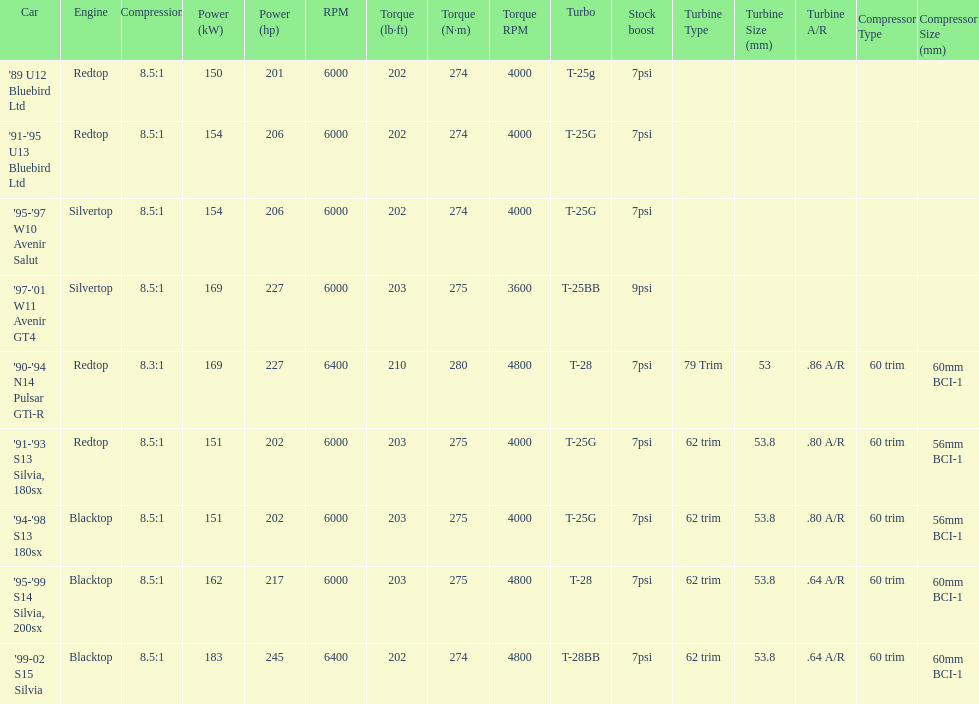Would you be able to parse every entry in this table? {'header': ['Car', 'Engine', 'Compression', 'Power (kW)', 'Power (hp)', 'RPM', 'Torque (lb·ft)', 'Torque (N·m)', 'Torque RPM', 'Turbo', 'Stock boost', 'Turbine Type', 'Turbine Size (mm)', 'Turbine A/R', 'Compressor Type', 'Compressor Size (mm)'], 'rows': [["'89 U12 Bluebird Ltd", 'Redtop', '8.5:1', '150', '201', '6000', '202', '274', '4000', 'T-25g', '7psi', '', '', '', '', ''], ["'91-'95 U13 Bluebird Ltd", 'Redtop', '8.5:1', '154', '206', '6000', '202', '274', '4000', 'T-25G', '7psi', '', '', '', '', ''], ["'95-'97 W10 Avenir Salut", 'Silvertop', '8.5:1', '154', '206', '6000', '202', '274', '4000', 'T-25G', '7psi', '', '', '', '', ''], ["'97-'01 W11 Avenir GT4", 'Silvertop', '8.5:1', '169', '227', '6000', '203', '275', '3600', 'T-25BB', '9psi', '', '', '', '', ''], ["'90-'94 N14 Pulsar GTi-R", 'Redtop', '8.3:1', '169', '227', '6400', '210', '280', '4800', 'T-28', '7psi', '79 Trim', '53', '.86 A/R', '60 trim', '60mm BCI-1'], ["'91-'93 S13 Silvia, 180sx", 'Redtop', '8.5:1', '151', '202', '6000', '203', '275', '4000', 'T-25G', '7psi', '62 trim', '53.8', '.80 A/R', '60 trim', '56mm BCI-1'], ["'94-'98 S13 180sx", 'Blacktop', '8.5:1', '151', '202', '6000', '203', '275', '4000', 'T-25G', '7psi', '62 trim', '53.8', '.80 A/R', '60 trim', '56mm BCI-1'], ["'95-'99 S14 Silvia, 200sx", 'Blacktop', '8.5:1', '162', '217', '6000', '203', '275', '4800', 'T-28', '7psi', '62 trim', '53.8', '.64 A/R', '60 trim', '60mm BCI-1'], ["'99-02 S15 Silvia", 'Blacktop', '8.5:1', '183', '245', '6400', '202', '274', '4800', 'T-28BB', '7psi', '62 trim', '53.8', '.64 A/R', '60 trim', '60mm BCI-1']]} Which engines are the same as the first entry ('89 u12 bluebird ltd)? '91-'95 U13 Bluebird Ltd, '90-'94 N14 Pulsar GTi-R, '91-'93 S13 Silvia, 180sx. 